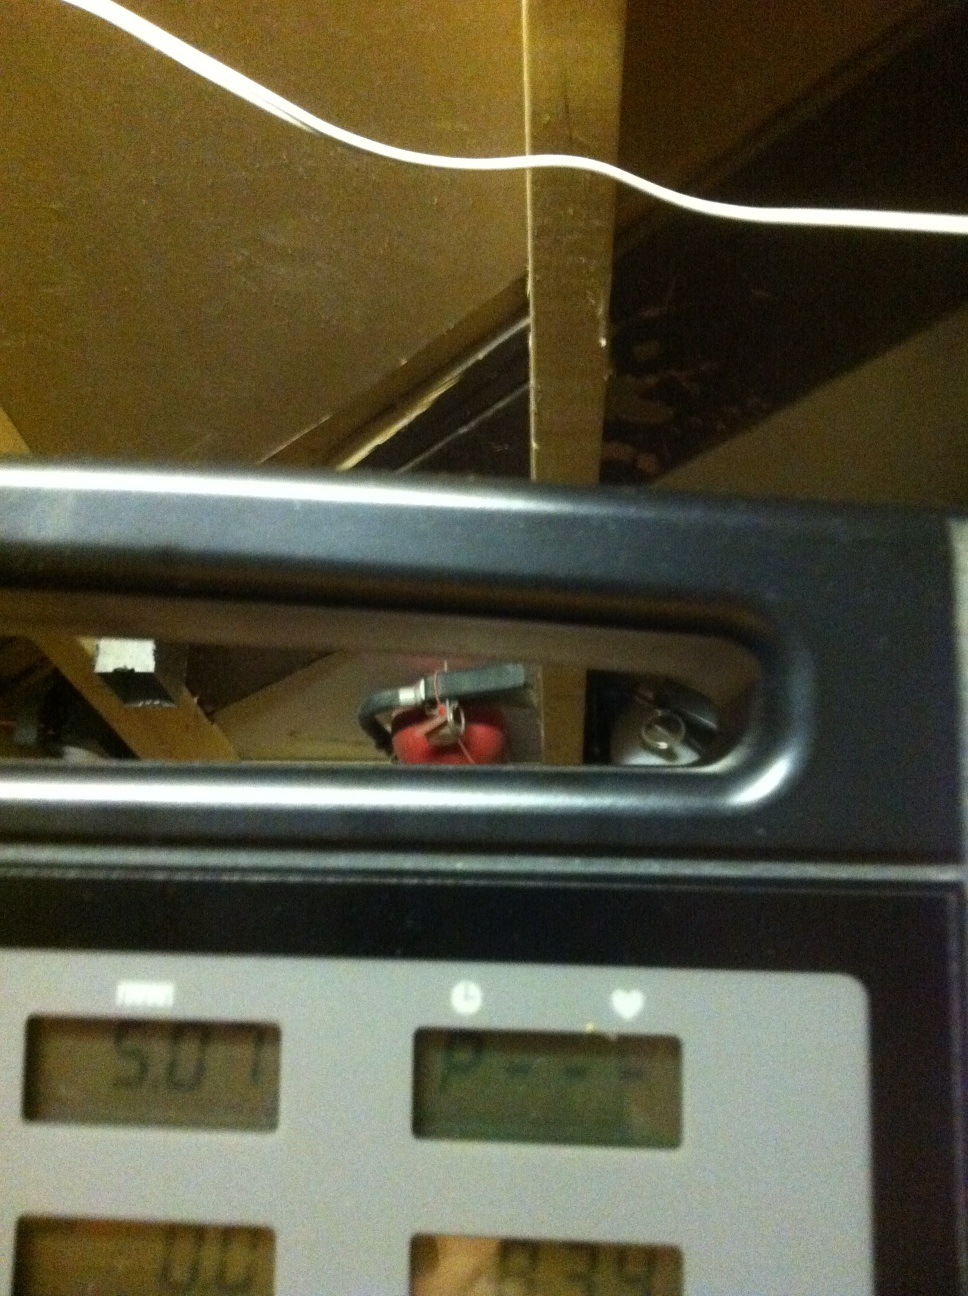What safety features can I see in this image, and how does it relate to using the treadmill safely? In the image, you can see a red fire extinguisher mounted in the background, which is a general safety feature of the room where the treadmill is located. However, when using the treadmill, it is important to make sure that emergency stops or safety clips are appropriately attached and that the surroundings are clear to avoid any accidents. 